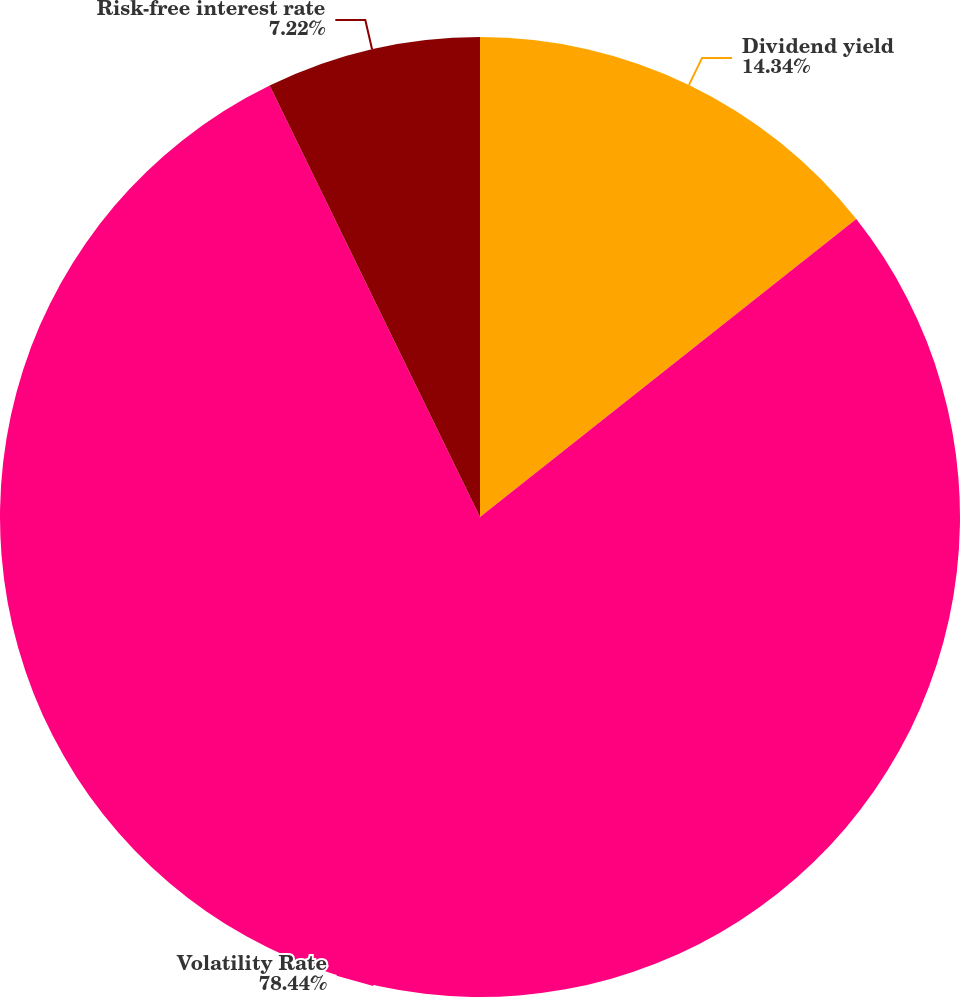<chart> <loc_0><loc_0><loc_500><loc_500><pie_chart><fcel>Dividend yield<fcel>Volatility Rate<fcel>Risk-free interest rate<nl><fcel>14.34%<fcel>78.44%<fcel>7.22%<nl></chart> 